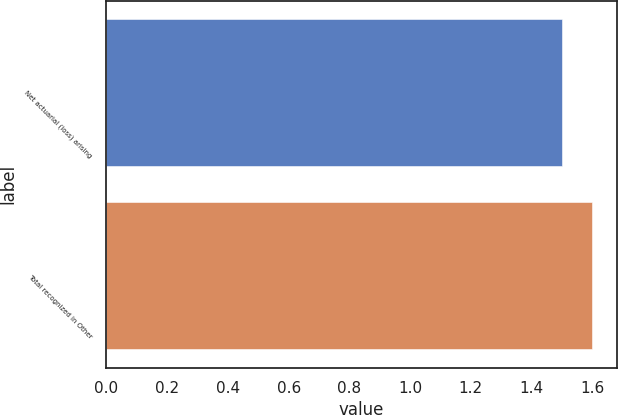<chart> <loc_0><loc_0><loc_500><loc_500><bar_chart><fcel>Net actuarial (loss) arising<fcel>Total recognized in Other<nl><fcel>1.5<fcel>1.6<nl></chart> 